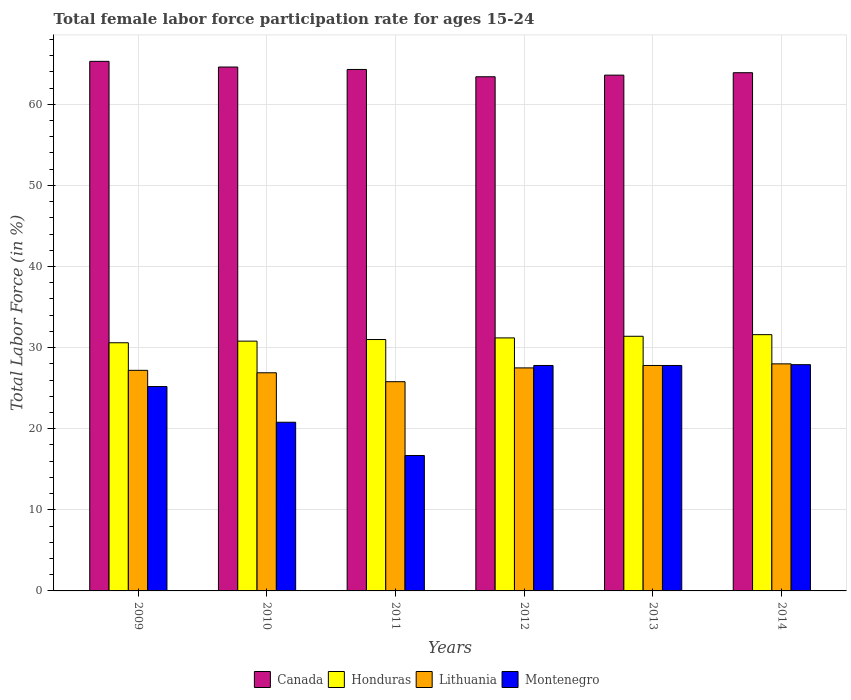How many different coloured bars are there?
Make the answer very short. 4. Are the number of bars on each tick of the X-axis equal?
Provide a succinct answer. Yes. In how many cases, is the number of bars for a given year not equal to the number of legend labels?
Your answer should be compact. 0. What is the female labor force participation rate in Honduras in 2014?
Offer a terse response. 31.6. Across all years, what is the minimum female labor force participation rate in Lithuania?
Offer a very short reply. 25.8. In which year was the female labor force participation rate in Montenegro minimum?
Your answer should be compact. 2011. What is the total female labor force participation rate in Canada in the graph?
Offer a terse response. 385.1. What is the difference between the female labor force participation rate in Canada in 2009 and the female labor force participation rate in Lithuania in 2012?
Provide a short and direct response. 37.8. What is the average female labor force participation rate in Canada per year?
Your answer should be compact. 64.18. In the year 2011, what is the difference between the female labor force participation rate in Honduras and female labor force participation rate in Canada?
Offer a very short reply. -33.3. In how many years, is the female labor force participation rate in Montenegro greater than 28 %?
Keep it short and to the point. 0. What is the ratio of the female labor force participation rate in Montenegro in 2011 to that in 2014?
Give a very brief answer. 0.6. Is the female labor force participation rate in Montenegro in 2012 less than that in 2013?
Provide a succinct answer. No. What is the difference between the highest and the second highest female labor force participation rate in Lithuania?
Provide a short and direct response. 0.2. What is the difference between the highest and the lowest female labor force participation rate in Lithuania?
Offer a terse response. 2.2. In how many years, is the female labor force participation rate in Lithuania greater than the average female labor force participation rate in Lithuania taken over all years?
Ensure brevity in your answer.  4. What does the 4th bar from the left in 2014 represents?
Give a very brief answer. Montenegro. What does the 1st bar from the right in 2010 represents?
Offer a very short reply. Montenegro. How many years are there in the graph?
Make the answer very short. 6. What is the difference between two consecutive major ticks on the Y-axis?
Your answer should be very brief. 10. Does the graph contain any zero values?
Give a very brief answer. No. Does the graph contain grids?
Provide a succinct answer. Yes. How many legend labels are there?
Your answer should be very brief. 4. What is the title of the graph?
Ensure brevity in your answer.  Total female labor force participation rate for ages 15-24. What is the Total Labor Force (in %) in Canada in 2009?
Your answer should be very brief. 65.3. What is the Total Labor Force (in %) of Honduras in 2009?
Provide a short and direct response. 30.6. What is the Total Labor Force (in %) of Lithuania in 2009?
Your response must be concise. 27.2. What is the Total Labor Force (in %) of Montenegro in 2009?
Keep it short and to the point. 25.2. What is the Total Labor Force (in %) in Canada in 2010?
Make the answer very short. 64.6. What is the Total Labor Force (in %) in Honduras in 2010?
Make the answer very short. 30.8. What is the Total Labor Force (in %) in Lithuania in 2010?
Your response must be concise. 26.9. What is the Total Labor Force (in %) of Montenegro in 2010?
Your response must be concise. 20.8. What is the Total Labor Force (in %) in Canada in 2011?
Your response must be concise. 64.3. What is the Total Labor Force (in %) in Lithuania in 2011?
Your answer should be compact. 25.8. What is the Total Labor Force (in %) of Montenegro in 2011?
Offer a terse response. 16.7. What is the Total Labor Force (in %) in Canada in 2012?
Provide a short and direct response. 63.4. What is the Total Labor Force (in %) of Honduras in 2012?
Make the answer very short. 31.2. What is the Total Labor Force (in %) in Montenegro in 2012?
Offer a very short reply. 27.8. What is the Total Labor Force (in %) of Canada in 2013?
Offer a terse response. 63.6. What is the Total Labor Force (in %) of Honduras in 2013?
Offer a very short reply. 31.4. What is the Total Labor Force (in %) of Lithuania in 2013?
Your answer should be very brief. 27.8. What is the Total Labor Force (in %) in Montenegro in 2013?
Your answer should be very brief. 27.8. What is the Total Labor Force (in %) in Canada in 2014?
Make the answer very short. 63.9. What is the Total Labor Force (in %) of Honduras in 2014?
Provide a succinct answer. 31.6. What is the Total Labor Force (in %) of Montenegro in 2014?
Offer a very short reply. 27.9. Across all years, what is the maximum Total Labor Force (in %) in Canada?
Ensure brevity in your answer.  65.3. Across all years, what is the maximum Total Labor Force (in %) of Honduras?
Offer a terse response. 31.6. Across all years, what is the maximum Total Labor Force (in %) of Montenegro?
Ensure brevity in your answer.  27.9. Across all years, what is the minimum Total Labor Force (in %) in Canada?
Make the answer very short. 63.4. Across all years, what is the minimum Total Labor Force (in %) of Honduras?
Keep it short and to the point. 30.6. Across all years, what is the minimum Total Labor Force (in %) of Lithuania?
Your answer should be compact. 25.8. Across all years, what is the minimum Total Labor Force (in %) of Montenegro?
Your answer should be very brief. 16.7. What is the total Total Labor Force (in %) in Canada in the graph?
Keep it short and to the point. 385.1. What is the total Total Labor Force (in %) of Honduras in the graph?
Offer a very short reply. 186.6. What is the total Total Labor Force (in %) in Lithuania in the graph?
Make the answer very short. 163.2. What is the total Total Labor Force (in %) in Montenegro in the graph?
Offer a terse response. 146.2. What is the difference between the Total Labor Force (in %) of Honduras in 2009 and that in 2010?
Your response must be concise. -0.2. What is the difference between the Total Labor Force (in %) in Lithuania in 2009 and that in 2010?
Your answer should be compact. 0.3. What is the difference between the Total Labor Force (in %) in Montenegro in 2009 and that in 2010?
Ensure brevity in your answer.  4.4. What is the difference between the Total Labor Force (in %) in Honduras in 2009 and that in 2011?
Offer a terse response. -0.4. What is the difference between the Total Labor Force (in %) in Montenegro in 2009 and that in 2011?
Provide a succinct answer. 8.5. What is the difference between the Total Labor Force (in %) of Montenegro in 2009 and that in 2012?
Offer a very short reply. -2.6. What is the difference between the Total Labor Force (in %) of Canada in 2009 and that in 2013?
Your answer should be compact. 1.7. What is the difference between the Total Labor Force (in %) in Honduras in 2009 and that in 2014?
Offer a very short reply. -1. What is the difference between the Total Labor Force (in %) in Lithuania in 2009 and that in 2014?
Give a very brief answer. -0.8. What is the difference between the Total Labor Force (in %) of Montenegro in 2009 and that in 2014?
Your answer should be very brief. -2.7. What is the difference between the Total Labor Force (in %) of Montenegro in 2010 and that in 2011?
Ensure brevity in your answer.  4.1. What is the difference between the Total Labor Force (in %) in Canada in 2010 and that in 2012?
Provide a short and direct response. 1.2. What is the difference between the Total Labor Force (in %) of Honduras in 2010 and that in 2012?
Offer a very short reply. -0.4. What is the difference between the Total Labor Force (in %) of Lithuania in 2010 and that in 2012?
Ensure brevity in your answer.  -0.6. What is the difference between the Total Labor Force (in %) of Montenegro in 2010 and that in 2014?
Provide a succinct answer. -7.1. What is the difference between the Total Labor Force (in %) in Canada in 2011 and that in 2012?
Provide a short and direct response. 0.9. What is the difference between the Total Labor Force (in %) of Honduras in 2011 and that in 2012?
Make the answer very short. -0.2. What is the difference between the Total Labor Force (in %) of Montenegro in 2011 and that in 2012?
Your response must be concise. -11.1. What is the difference between the Total Labor Force (in %) in Honduras in 2011 and that in 2013?
Your response must be concise. -0.4. What is the difference between the Total Labor Force (in %) in Lithuania in 2011 and that in 2013?
Your answer should be very brief. -2. What is the difference between the Total Labor Force (in %) of Honduras in 2011 and that in 2014?
Keep it short and to the point. -0.6. What is the difference between the Total Labor Force (in %) in Lithuania in 2011 and that in 2014?
Give a very brief answer. -2.2. What is the difference between the Total Labor Force (in %) of Honduras in 2012 and that in 2013?
Make the answer very short. -0.2. What is the difference between the Total Labor Force (in %) of Canada in 2012 and that in 2014?
Keep it short and to the point. -0.5. What is the difference between the Total Labor Force (in %) in Honduras in 2012 and that in 2014?
Offer a very short reply. -0.4. What is the difference between the Total Labor Force (in %) of Lithuania in 2012 and that in 2014?
Your answer should be very brief. -0.5. What is the difference between the Total Labor Force (in %) in Montenegro in 2012 and that in 2014?
Your response must be concise. -0.1. What is the difference between the Total Labor Force (in %) in Canada in 2013 and that in 2014?
Your answer should be compact. -0.3. What is the difference between the Total Labor Force (in %) in Canada in 2009 and the Total Labor Force (in %) in Honduras in 2010?
Give a very brief answer. 34.5. What is the difference between the Total Labor Force (in %) in Canada in 2009 and the Total Labor Force (in %) in Lithuania in 2010?
Provide a succinct answer. 38.4. What is the difference between the Total Labor Force (in %) in Canada in 2009 and the Total Labor Force (in %) in Montenegro in 2010?
Keep it short and to the point. 44.5. What is the difference between the Total Labor Force (in %) of Honduras in 2009 and the Total Labor Force (in %) of Lithuania in 2010?
Your answer should be compact. 3.7. What is the difference between the Total Labor Force (in %) of Honduras in 2009 and the Total Labor Force (in %) of Montenegro in 2010?
Offer a terse response. 9.8. What is the difference between the Total Labor Force (in %) of Lithuania in 2009 and the Total Labor Force (in %) of Montenegro in 2010?
Your answer should be very brief. 6.4. What is the difference between the Total Labor Force (in %) of Canada in 2009 and the Total Labor Force (in %) of Honduras in 2011?
Provide a succinct answer. 34.3. What is the difference between the Total Labor Force (in %) of Canada in 2009 and the Total Labor Force (in %) of Lithuania in 2011?
Your answer should be compact. 39.5. What is the difference between the Total Labor Force (in %) in Canada in 2009 and the Total Labor Force (in %) in Montenegro in 2011?
Your answer should be compact. 48.6. What is the difference between the Total Labor Force (in %) of Lithuania in 2009 and the Total Labor Force (in %) of Montenegro in 2011?
Your response must be concise. 10.5. What is the difference between the Total Labor Force (in %) in Canada in 2009 and the Total Labor Force (in %) in Honduras in 2012?
Your answer should be very brief. 34.1. What is the difference between the Total Labor Force (in %) of Canada in 2009 and the Total Labor Force (in %) of Lithuania in 2012?
Provide a succinct answer. 37.8. What is the difference between the Total Labor Force (in %) in Canada in 2009 and the Total Labor Force (in %) in Montenegro in 2012?
Make the answer very short. 37.5. What is the difference between the Total Labor Force (in %) in Honduras in 2009 and the Total Labor Force (in %) in Lithuania in 2012?
Make the answer very short. 3.1. What is the difference between the Total Labor Force (in %) of Honduras in 2009 and the Total Labor Force (in %) of Montenegro in 2012?
Make the answer very short. 2.8. What is the difference between the Total Labor Force (in %) in Canada in 2009 and the Total Labor Force (in %) in Honduras in 2013?
Offer a very short reply. 33.9. What is the difference between the Total Labor Force (in %) of Canada in 2009 and the Total Labor Force (in %) of Lithuania in 2013?
Provide a short and direct response. 37.5. What is the difference between the Total Labor Force (in %) in Canada in 2009 and the Total Labor Force (in %) in Montenegro in 2013?
Your answer should be compact. 37.5. What is the difference between the Total Labor Force (in %) of Honduras in 2009 and the Total Labor Force (in %) of Lithuania in 2013?
Keep it short and to the point. 2.8. What is the difference between the Total Labor Force (in %) of Lithuania in 2009 and the Total Labor Force (in %) of Montenegro in 2013?
Your answer should be compact. -0.6. What is the difference between the Total Labor Force (in %) in Canada in 2009 and the Total Labor Force (in %) in Honduras in 2014?
Your answer should be compact. 33.7. What is the difference between the Total Labor Force (in %) in Canada in 2009 and the Total Labor Force (in %) in Lithuania in 2014?
Give a very brief answer. 37.3. What is the difference between the Total Labor Force (in %) in Canada in 2009 and the Total Labor Force (in %) in Montenegro in 2014?
Keep it short and to the point. 37.4. What is the difference between the Total Labor Force (in %) of Honduras in 2009 and the Total Labor Force (in %) of Montenegro in 2014?
Your answer should be very brief. 2.7. What is the difference between the Total Labor Force (in %) in Canada in 2010 and the Total Labor Force (in %) in Honduras in 2011?
Keep it short and to the point. 33.6. What is the difference between the Total Labor Force (in %) in Canada in 2010 and the Total Labor Force (in %) in Lithuania in 2011?
Your answer should be very brief. 38.8. What is the difference between the Total Labor Force (in %) of Canada in 2010 and the Total Labor Force (in %) of Montenegro in 2011?
Offer a terse response. 47.9. What is the difference between the Total Labor Force (in %) of Lithuania in 2010 and the Total Labor Force (in %) of Montenegro in 2011?
Ensure brevity in your answer.  10.2. What is the difference between the Total Labor Force (in %) of Canada in 2010 and the Total Labor Force (in %) of Honduras in 2012?
Offer a terse response. 33.4. What is the difference between the Total Labor Force (in %) in Canada in 2010 and the Total Labor Force (in %) in Lithuania in 2012?
Give a very brief answer. 37.1. What is the difference between the Total Labor Force (in %) in Canada in 2010 and the Total Labor Force (in %) in Montenegro in 2012?
Make the answer very short. 36.8. What is the difference between the Total Labor Force (in %) of Honduras in 2010 and the Total Labor Force (in %) of Lithuania in 2012?
Your answer should be compact. 3.3. What is the difference between the Total Labor Force (in %) of Honduras in 2010 and the Total Labor Force (in %) of Montenegro in 2012?
Provide a short and direct response. 3. What is the difference between the Total Labor Force (in %) of Lithuania in 2010 and the Total Labor Force (in %) of Montenegro in 2012?
Give a very brief answer. -0.9. What is the difference between the Total Labor Force (in %) of Canada in 2010 and the Total Labor Force (in %) of Honduras in 2013?
Your answer should be compact. 33.2. What is the difference between the Total Labor Force (in %) in Canada in 2010 and the Total Labor Force (in %) in Lithuania in 2013?
Offer a terse response. 36.8. What is the difference between the Total Labor Force (in %) in Canada in 2010 and the Total Labor Force (in %) in Montenegro in 2013?
Your answer should be very brief. 36.8. What is the difference between the Total Labor Force (in %) in Honduras in 2010 and the Total Labor Force (in %) in Montenegro in 2013?
Offer a terse response. 3. What is the difference between the Total Labor Force (in %) in Lithuania in 2010 and the Total Labor Force (in %) in Montenegro in 2013?
Keep it short and to the point. -0.9. What is the difference between the Total Labor Force (in %) in Canada in 2010 and the Total Labor Force (in %) in Lithuania in 2014?
Give a very brief answer. 36.6. What is the difference between the Total Labor Force (in %) of Canada in 2010 and the Total Labor Force (in %) of Montenegro in 2014?
Keep it short and to the point. 36.7. What is the difference between the Total Labor Force (in %) of Honduras in 2010 and the Total Labor Force (in %) of Montenegro in 2014?
Keep it short and to the point. 2.9. What is the difference between the Total Labor Force (in %) of Lithuania in 2010 and the Total Labor Force (in %) of Montenegro in 2014?
Your answer should be compact. -1. What is the difference between the Total Labor Force (in %) of Canada in 2011 and the Total Labor Force (in %) of Honduras in 2012?
Your response must be concise. 33.1. What is the difference between the Total Labor Force (in %) in Canada in 2011 and the Total Labor Force (in %) in Lithuania in 2012?
Make the answer very short. 36.8. What is the difference between the Total Labor Force (in %) in Canada in 2011 and the Total Labor Force (in %) in Montenegro in 2012?
Provide a succinct answer. 36.5. What is the difference between the Total Labor Force (in %) in Honduras in 2011 and the Total Labor Force (in %) in Lithuania in 2012?
Give a very brief answer. 3.5. What is the difference between the Total Labor Force (in %) in Canada in 2011 and the Total Labor Force (in %) in Honduras in 2013?
Your answer should be compact. 32.9. What is the difference between the Total Labor Force (in %) of Canada in 2011 and the Total Labor Force (in %) of Lithuania in 2013?
Provide a succinct answer. 36.5. What is the difference between the Total Labor Force (in %) of Canada in 2011 and the Total Labor Force (in %) of Montenegro in 2013?
Give a very brief answer. 36.5. What is the difference between the Total Labor Force (in %) in Honduras in 2011 and the Total Labor Force (in %) in Lithuania in 2013?
Provide a succinct answer. 3.2. What is the difference between the Total Labor Force (in %) of Lithuania in 2011 and the Total Labor Force (in %) of Montenegro in 2013?
Offer a terse response. -2. What is the difference between the Total Labor Force (in %) in Canada in 2011 and the Total Labor Force (in %) in Honduras in 2014?
Your answer should be compact. 32.7. What is the difference between the Total Labor Force (in %) of Canada in 2011 and the Total Labor Force (in %) of Lithuania in 2014?
Keep it short and to the point. 36.3. What is the difference between the Total Labor Force (in %) in Canada in 2011 and the Total Labor Force (in %) in Montenegro in 2014?
Make the answer very short. 36.4. What is the difference between the Total Labor Force (in %) of Honduras in 2011 and the Total Labor Force (in %) of Montenegro in 2014?
Your answer should be very brief. 3.1. What is the difference between the Total Labor Force (in %) in Canada in 2012 and the Total Labor Force (in %) in Lithuania in 2013?
Make the answer very short. 35.6. What is the difference between the Total Labor Force (in %) in Canada in 2012 and the Total Labor Force (in %) in Montenegro in 2013?
Your answer should be compact. 35.6. What is the difference between the Total Labor Force (in %) in Honduras in 2012 and the Total Labor Force (in %) in Lithuania in 2013?
Your response must be concise. 3.4. What is the difference between the Total Labor Force (in %) in Canada in 2012 and the Total Labor Force (in %) in Honduras in 2014?
Make the answer very short. 31.8. What is the difference between the Total Labor Force (in %) in Canada in 2012 and the Total Labor Force (in %) in Lithuania in 2014?
Your answer should be very brief. 35.4. What is the difference between the Total Labor Force (in %) of Canada in 2012 and the Total Labor Force (in %) of Montenegro in 2014?
Your answer should be very brief. 35.5. What is the difference between the Total Labor Force (in %) of Honduras in 2012 and the Total Labor Force (in %) of Montenegro in 2014?
Keep it short and to the point. 3.3. What is the difference between the Total Labor Force (in %) in Canada in 2013 and the Total Labor Force (in %) in Lithuania in 2014?
Offer a terse response. 35.6. What is the difference between the Total Labor Force (in %) of Canada in 2013 and the Total Labor Force (in %) of Montenegro in 2014?
Make the answer very short. 35.7. What is the difference between the Total Labor Force (in %) in Honduras in 2013 and the Total Labor Force (in %) in Lithuania in 2014?
Your answer should be very brief. 3.4. What is the average Total Labor Force (in %) in Canada per year?
Offer a very short reply. 64.18. What is the average Total Labor Force (in %) of Honduras per year?
Your answer should be compact. 31.1. What is the average Total Labor Force (in %) in Lithuania per year?
Your answer should be compact. 27.2. What is the average Total Labor Force (in %) in Montenegro per year?
Your answer should be very brief. 24.37. In the year 2009, what is the difference between the Total Labor Force (in %) of Canada and Total Labor Force (in %) of Honduras?
Your response must be concise. 34.7. In the year 2009, what is the difference between the Total Labor Force (in %) in Canada and Total Labor Force (in %) in Lithuania?
Provide a succinct answer. 38.1. In the year 2009, what is the difference between the Total Labor Force (in %) in Canada and Total Labor Force (in %) in Montenegro?
Offer a terse response. 40.1. In the year 2009, what is the difference between the Total Labor Force (in %) in Honduras and Total Labor Force (in %) in Lithuania?
Provide a short and direct response. 3.4. In the year 2009, what is the difference between the Total Labor Force (in %) of Honduras and Total Labor Force (in %) of Montenegro?
Your answer should be compact. 5.4. In the year 2010, what is the difference between the Total Labor Force (in %) in Canada and Total Labor Force (in %) in Honduras?
Provide a short and direct response. 33.8. In the year 2010, what is the difference between the Total Labor Force (in %) in Canada and Total Labor Force (in %) in Lithuania?
Give a very brief answer. 37.7. In the year 2010, what is the difference between the Total Labor Force (in %) of Canada and Total Labor Force (in %) of Montenegro?
Offer a terse response. 43.8. In the year 2010, what is the difference between the Total Labor Force (in %) in Honduras and Total Labor Force (in %) in Montenegro?
Your response must be concise. 10. In the year 2011, what is the difference between the Total Labor Force (in %) in Canada and Total Labor Force (in %) in Honduras?
Give a very brief answer. 33.3. In the year 2011, what is the difference between the Total Labor Force (in %) of Canada and Total Labor Force (in %) of Lithuania?
Your response must be concise. 38.5. In the year 2011, what is the difference between the Total Labor Force (in %) of Canada and Total Labor Force (in %) of Montenegro?
Your answer should be compact. 47.6. In the year 2011, what is the difference between the Total Labor Force (in %) in Honduras and Total Labor Force (in %) in Lithuania?
Make the answer very short. 5.2. In the year 2011, what is the difference between the Total Labor Force (in %) in Lithuania and Total Labor Force (in %) in Montenegro?
Your response must be concise. 9.1. In the year 2012, what is the difference between the Total Labor Force (in %) of Canada and Total Labor Force (in %) of Honduras?
Provide a succinct answer. 32.2. In the year 2012, what is the difference between the Total Labor Force (in %) of Canada and Total Labor Force (in %) of Lithuania?
Give a very brief answer. 35.9. In the year 2012, what is the difference between the Total Labor Force (in %) of Canada and Total Labor Force (in %) of Montenegro?
Provide a short and direct response. 35.6. In the year 2012, what is the difference between the Total Labor Force (in %) in Honduras and Total Labor Force (in %) in Lithuania?
Offer a terse response. 3.7. In the year 2012, what is the difference between the Total Labor Force (in %) in Honduras and Total Labor Force (in %) in Montenegro?
Provide a short and direct response. 3.4. In the year 2012, what is the difference between the Total Labor Force (in %) of Lithuania and Total Labor Force (in %) of Montenegro?
Provide a succinct answer. -0.3. In the year 2013, what is the difference between the Total Labor Force (in %) of Canada and Total Labor Force (in %) of Honduras?
Offer a very short reply. 32.2. In the year 2013, what is the difference between the Total Labor Force (in %) in Canada and Total Labor Force (in %) in Lithuania?
Provide a short and direct response. 35.8. In the year 2013, what is the difference between the Total Labor Force (in %) of Canada and Total Labor Force (in %) of Montenegro?
Offer a very short reply. 35.8. In the year 2013, what is the difference between the Total Labor Force (in %) of Honduras and Total Labor Force (in %) of Montenegro?
Provide a succinct answer. 3.6. In the year 2013, what is the difference between the Total Labor Force (in %) of Lithuania and Total Labor Force (in %) of Montenegro?
Provide a succinct answer. 0. In the year 2014, what is the difference between the Total Labor Force (in %) in Canada and Total Labor Force (in %) in Honduras?
Ensure brevity in your answer.  32.3. In the year 2014, what is the difference between the Total Labor Force (in %) in Canada and Total Labor Force (in %) in Lithuania?
Provide a succinct answer. 35.9. In the year 2014, what is the difference between the Total Labor Force (in %) in Canada and Total Labor Force (in %) in Montenegro?
Provide a succinct answer. 36. In the year 2014, what is the difference between the Total Labor Force (in %) of Honduras and Total Labor Force (in %) of Montenegro?
Your response must be concise. 3.7. In the year 2014, what is the difference between the Total Labor Force (in %) of Lithuania and Total Labor Force (in %) of Montenegro?
Offer a very short reply. 0.1. What is the ratio of the Total Labor Force (in %) of Canada in 2009 to that in 2010?
Your answer should be very brief. 1.01. What is the ratio of the Total Labor Force (in %) in Honduras in 2009 to that in 2010?
Ensure brevity in your answer.  0.99. What is the ratio of the Total Labor Force (in %) in Lithuania in 2009 to that in 2010?
Your answer should be compact. 1.01. What is the ratio of the Total Labor Force (in %) in Montenegro in 2009 to that in 2010?
Your answer should be very brief. 1.21. What is the ratio of the Total Labor Force (in %) in Canada in 2009 to that in 2011?
Your answer should be very brief. 1.02. What is the ratio of the Total Labor Force (in %) in Honduras in 2009 to that in 2011?
Give a very brief answer. 0.99. What is the ratio of the Total Labor Force (in %) of Lithuania in 2009 to that in 2011?
Your answer should be very brief. 1.05. What is the ratio of the Total Labor Force (in %) in Montenegro in 2009 to that in 2011?
Offer a terse response. 1.51. What is the ratio of the Total Labor Force (in %) of Canada in 2009 to that in 2012?
Your answer should be compact. 1.03. What is the ratio of the Total Labor Force (in %) of Honduras in 2009 to that in 2012?
Offer a terse response. 0.98. What is the ratio of the Total Labor Force (in %) in Montenegro in 2009 to that in 2012?
Give a very brief answer. 0.91. What is the ratio of the Total Labor Force (in %) in Canada in 2009 to that in 2013?
Your answer should be very brief. 1.03. What is the ratio of the Total Labor Force (in %) in Honduras in 2009 to that in 2013?
Provide a succinct answer. 0.97. What is the ratio of the Total Labor Force (in %) in Lithuania in 2009 to that in 2013?
Provide a short and direct response. 0.98. What is the ratio of the Total Labor Force (in %) in Montenegro in 2009 to that in 2013?
Your answer should be compact. 0.91. What is the ratio of the Total Labor Force (in %) in Canada in 2009 to that in 2014?
Keep it short and to the point. 1.02. What is the ratio of the Total Labor Force (in %) in Honduras in 2009 to that in 2014?
Offer a very short reply. 0.97. What is the ratio of the Total Labor Force (in %) in Lithuania in 2009 to that in 2014?
Your response must be concise. 0.97. What is the ratio of the Total Labor Force (in %) of Montenegro in 2009 to that in 2014?
Ensure brevity in your answer.  0.9. What is the ratio of the Total Labor Force (in %) in Honduras in 2010 to that in 2011?
Give a very brief answer. 0.99. What is the ratio of the Total Labor Force (in %) in Lithuania in 2010 to that in 2011?
Provide a short and direct response. 1.04. What is the ratio of the Total Labor Force (in %) in Montenegro in 2010 to that in 2011?
Keep it short and to the point. 1.25. What is the ratio of the Total Labor Force (in %) of Canada in 2010 to that in 2012?
Your answer should be compact. 1.02. What is the ratio of the Total Labor Force (in %) of Honduras in 2010 to that in 2012?
Your response must be concise. 0.99. What is the ratio of the Total Labor Force (in %) in Lithuania in 2010 to that in 2012?
Make the answer very short. 0.98. What is the ratio of the Total Labor Force (in %) in Montenegro in 2010 to that in 2012?
Your answer should be very brief. 0.75. What is the ratio of the Total Labor Force (in %) of Canada in 2010 to that in 2013?
Offer a terse response. 1.02. What is the ratio of the Total Labor Force (in %) in Honduras in 2010 to that in 2013?
Provide a succinct answer. 0.98. What is the ratio of the Total Labor Force (in %) of Lithuania in 2010 to that in 2013?
Offer a very short reply. 0.97. What is the ratio of the Total Labor Force (in %) in Montenegro in 2010 to that in 2013?
Provide a short and direct response. 0.75. What is the ratio of the Total Labor Force (in %) in Canada in 2010 to that in 2014?
Keep it short and to the point. 1.01. What is the ratio of the Total Labor Force (in %) in Honduras in 2010 to that in 2014?
Ensure brevity in your answer.  0.97. What is the ratio of the Total Labor Force (in %) of Lithuania in 2010 to that in 2014?
Keep it short and to the point. 0.96. What is the ratio of the Total Labor Force (in %) in Montenegro in 2010 to that in 2014?
Your response must be concise. 0.75. What is the ratio of the Total Labor Force (in %) in Canada in 2011 to that in 2012?
Make the answer very short. 1.01. What is the ratio of the Total Labor Force (in %) of Lithuania in 2011 to that in 2012?
Ensure brevity in your answer.  0.94. What is the ratio of the Total Labor Force (in %) in Montenegro in 2011 to that in 2012?
Offer a very short reply. 0.6. What is the ratio of the Total Labor Force (in %) of Canada in 2011 to that in 2013?
Give a very brief answer. 1.01. What is the ratio of the Total Labor Force (in %) of Honduras in 2011 to that in 2013?
Provide a succinct answer. 0.99. What is the ratio of the Total Labor Force (in %) of Lithuania in 2011 to that in 2013?
Keep it short and to the point. 0.93. What is the ratio of the Total Labor Force (in %) in Montenegro in 2011 to that in 2013?
Your answer should be very brief. 0.6. What is the ratio of the Total Labor Force (in %) of Canada in 2011 to that in 2014?
Ensure brevity in your answer.  1.01. What is the ratio of the Total Labor Force (in %) of Honduras in 2011 to that in 2014?
Ensure brevity in your answer.  0.98. What is the ratio of the Total Labor Force (in %) of Lithuania in 2011 to that in 2014?
Your response must be concise. 0.92. What is the ratio of the Total Labor Force (in %) of Montenegro in 2011 to that in 2014?
Your answer should be compact. 0.6. What is the ratio of the Total Labor Force (in %) of Canada in 2012 to that in 2013?
Your answer should be compact. 1. What is the ratio of the Total Labor Force (in %) in Lithuania in 2012 to that in 2013?
Your answer should be compact. 0.99. What is the ratio of the Total Labor Force (in %) in Montenegro in 2012 to that in 2013?
Provide a succinct answer. 1. What is the ratio of the Total Labor Force (in %) of Canada in 2012 to that in 2014?
Make the answer very short. 0.99. What is the ratio of the Total Labor Force (in %) in Honduras in 2012 to that in 2014?
Ensure brevity in your answer.  0.99. What is the ratio of the Total Labor Force (in %) of Lithuania in 2012 to that in 2014?
Make the answer very short. 0.98. What is the ratio of the Total Labor Force (in %) of Canada in 2013 to that in 2014?
Give a very brief answer. 1. What is the difference between the highest and the second highest Total Labor Force (in %) in Honduras?
Your response must be concise. 0.2. What is the difference between the highest and the lowest Total Labor Force (in %) in Canada?
Offer a terse response. 1.9. What is the difference between the highest and the lowest Total Labor Force (in %) of Honduras?
Make the answer very short. 1. 